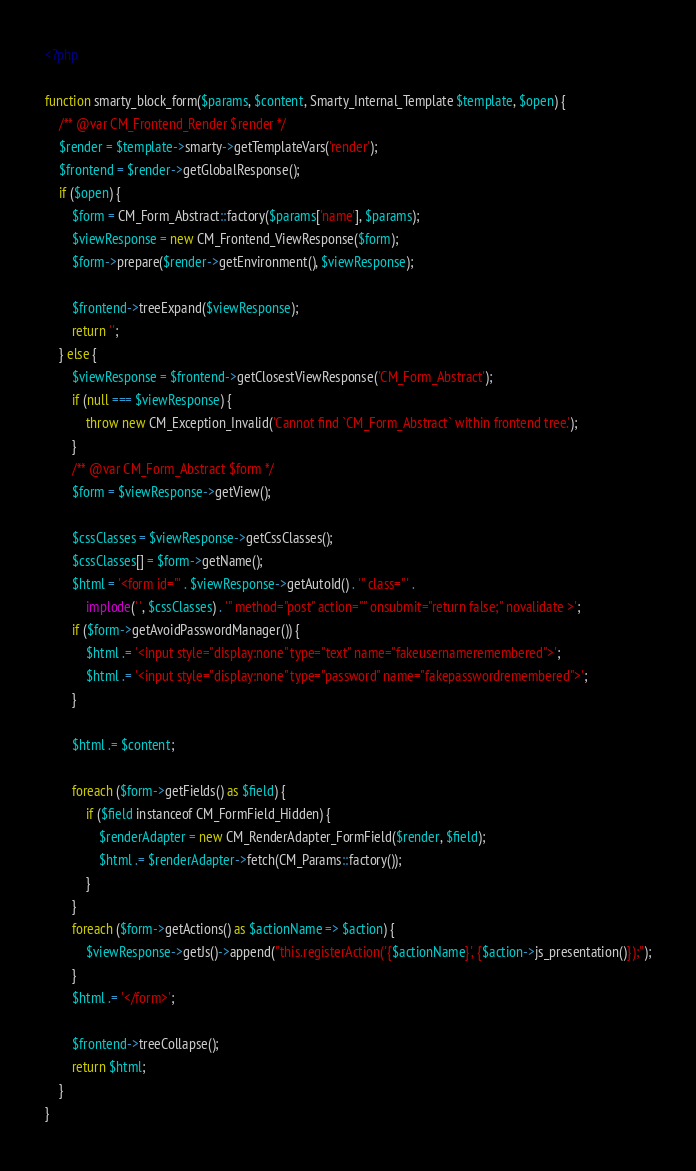<code> <loc_0><loc_0><loc_500><loc_500><_PHP_><?php

function smarty_block_form($params, $content, Smarty_Internal_Template $template, $open) {
    /** @var CM_Frontend_Render $render */
    $render = $template->smarty->getTemplateVars('render');
    $frontend = $render->getGlobalResponse();
    if ($open) {
        $form = CM_Form_Abstract::factory($params['name'], $params);
        $viewResponse = new CM_Frontend_ViewResponse($form);
        $form->prepare($render->getEnvironment(), $viewResponse);

        $frontend->treeExpand($viewResponse);
        return '';
    } else {
        $viewResponse = $frontend->getClosestViewResponse('CM_Form_Abstract');
        if (null === $viewResponse) {
            throw new CM_Exception_Invalid('Cannot find `CM_Form_Abstract` within frontend tree.');
        }
        /** @var CM_Form_Abstract $form */
        $form = $viewResponse->getView();

        $cssClasses = $viewResponse->getCssClasses();
        $cssClasses[] = $form->getName();
        $html = '<form id="' . $viewResponse->getAutoId() . '" class="' .
            implode(' ', $cssClasses) . '" method="post" action="" onsubmit="return false;" novalidate >';
        if ($form->getAvoidPasswordManager()) {
            $html .= '<input style="display:none" type="text" name="fakeusernameremembered">';
            $html .= '<input style="display:none" type="password" name="fakepasswordremembered">';
        }

        $html .= $content;

        foreach ($form->getFields() as $field) {
            if ($field instanceof CM_FormField_Hidden) {
                $renderAdapter = new CM_RenderAdapter_FormField($render, $field);
                $html .= $renderAdapter->fetch(CM_Params::factory());
            }
        }
        foreach ($form->getActions() as $actionName => $action) {
            $viewResponse->getJs()->append("this.registerAction('{$actionName}', {$action->js_presentation()});");
        }
        $html .= '</form>';

        $frontend->treeCollapse();
        return $html;
    }
}
</code> 